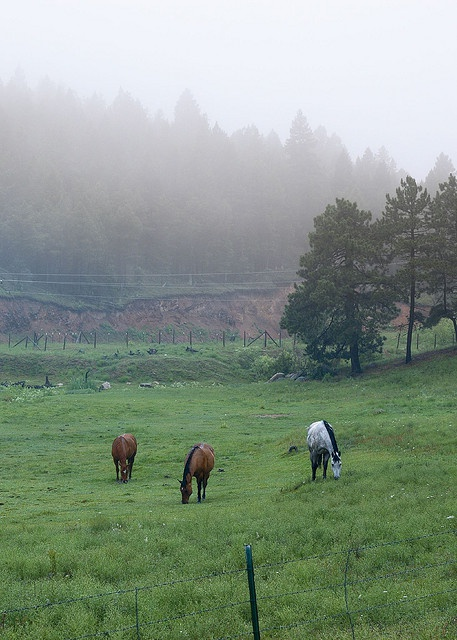Describe the objects in this image and their specific colors. I can see horse in white, black, gray, and darkgray tones, horse in white, black, gray, and maroon tones, and horse in white, black, maroon, and gray tones in this image. 